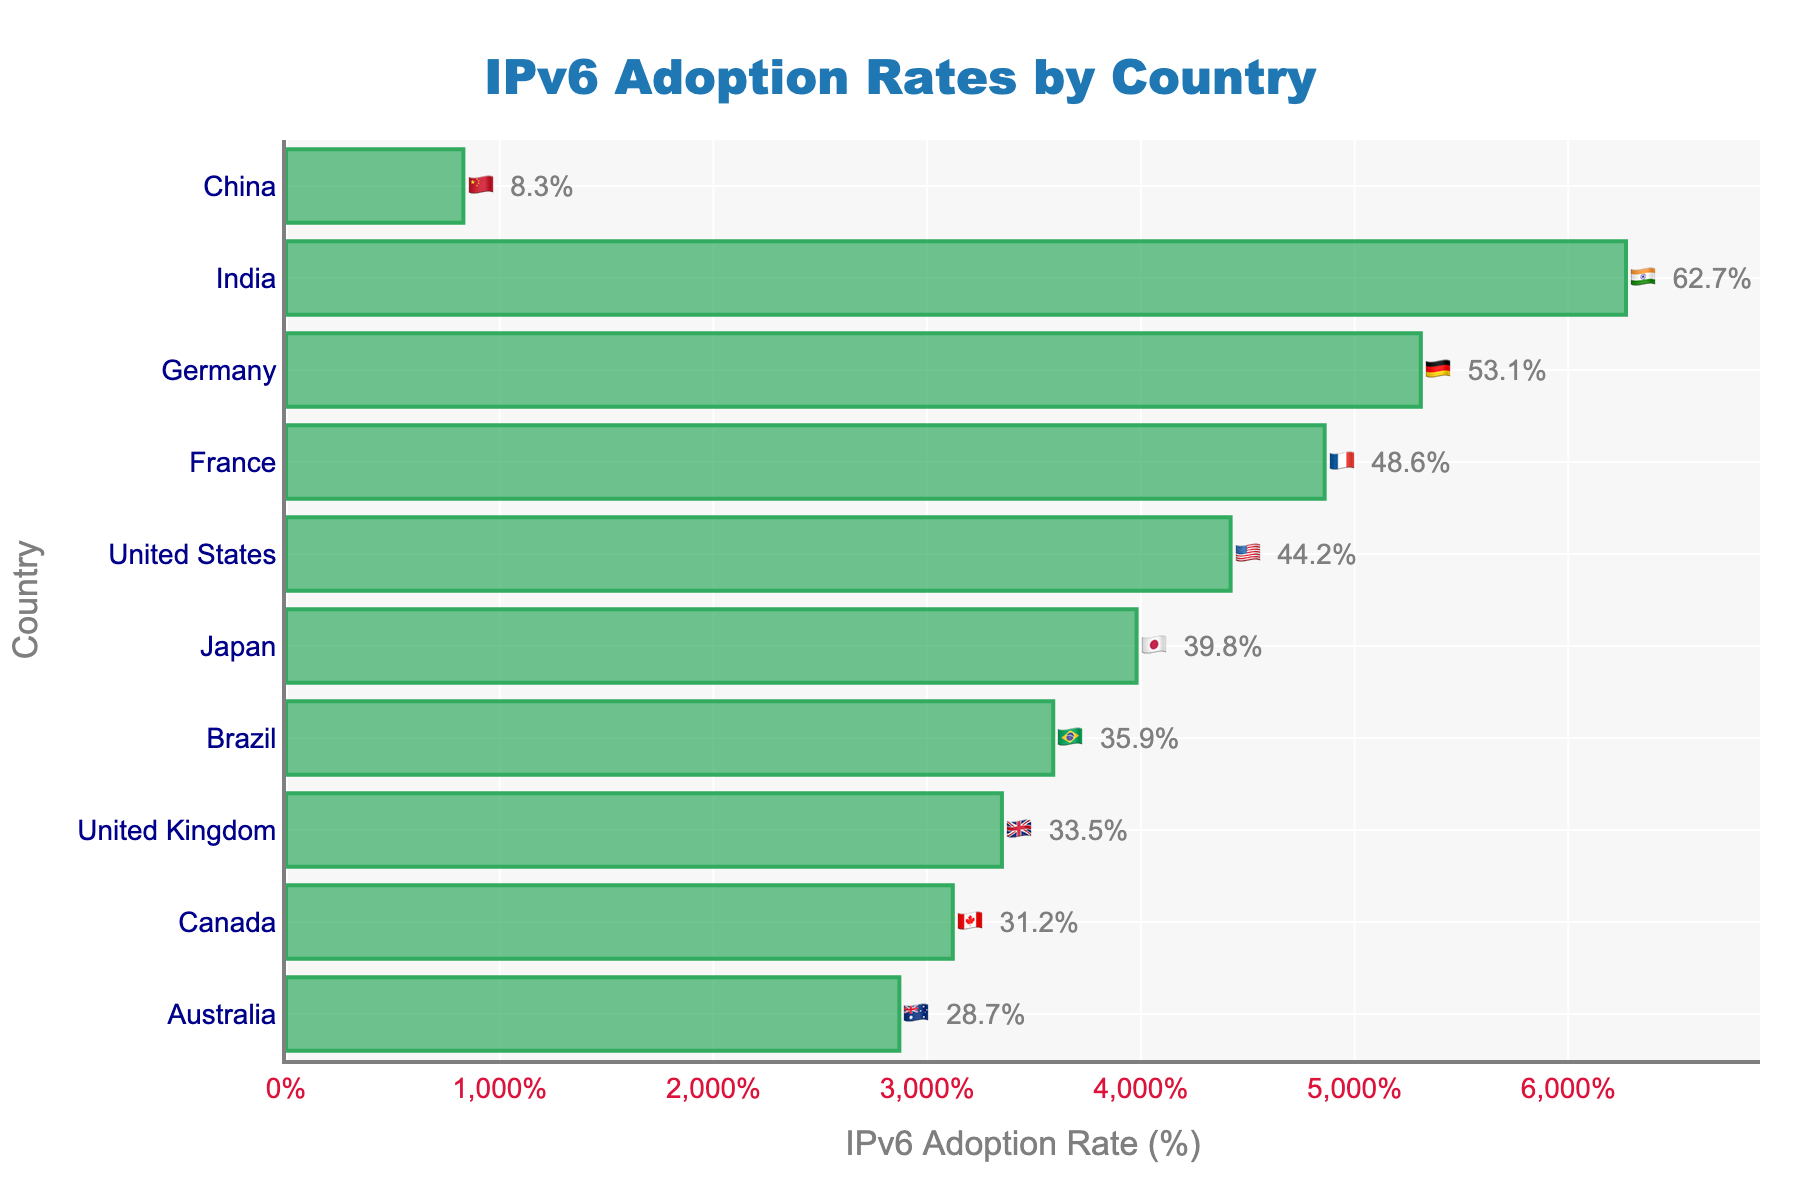Which country has the highest IPv6 adoption rate? The figure shows the adoption rates of IPv6 for different countries. By observing the length of the bars and the percentages displayed, we find that the country with the highest adoption rate is India with 62.7%.
Answer: India 🇮🇳 Which country has the lowest IPv6 adoption rate? The figure shows the adoption rates of IPv6 for different countries. By observing the length of the bars and the percentages displayed, we find that the country with the lowest adoption rate is China with 8.3%.
Answer: China 🇨🇳 What is the title of the figure? The title of the figure is always displayed at the top and typically larger and bolder than other text elements. In this figure, it reads "IPv6 Adoption Rates by Country".
Answer: IPv6 Adoption Rates by Country How many countries have an IPv6 adoption rate above 40%? By examining the bars and their corresponding percentages in the figure, we count the number of countries with adoption rates above 40%. Those countries are the United States, Japan, Germany, India, and France. Therefore, there are 5 countries.
Answer: 5 Which country has a higher IPv6 adoption rate, Brazil or Canada? To find this, compare the lengths of the bars for Brazil and Canada, as well as the percentages displayed. Brazil has an adoption rate of 35.9%, and Canada has an adoption rate of 31.2%. So, Brazil has a higher adoption rate.
Answer: Brazil 🇧🇷 What’s the difference in IPv6 adoption rates between the United Kingdom and Germany? By looking at the percentages displayed, the U.K. has an adoption rate of 33.5%, and Germany has 53.1%. The difference is calculated as 53.1% - 33.5% = 19.6%.
Answer: 19.6% Which countries have IPv6 adoption rates between 30% and 40%? By examining the figure, we look for countries within the specified range. Japan (39.8%), the United Kingdom (33.5%), Brazil (35.9%), and Canada (31.2%) fit this criterion.
Answer: Japan 🇯🇵, United Kingdom 🇬🇧, Brazil 🇧🇷, Canada 🇨🇦 Which two countries have the closest IPv6 adoption rates? Comparing the adoption rates, we determine which two are closest in value. The United States has 44.2%, and France has 48.6%. The difference is 48.6% - 44.2% = 4.4%, which is the smallest disparity among the pairs.
Answer: United States 🇺🇸 and France 🇫🇷 